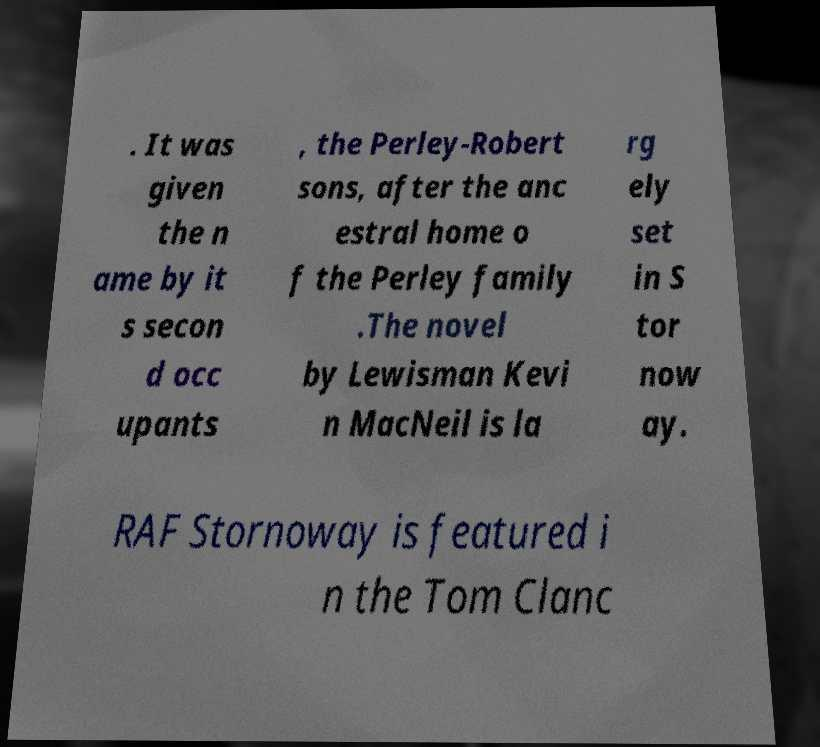There's text embedded in this image that I need extracted. Can you transcribe it verbatim? . It was given the n ame by it s secon d occ upants , the Perley-Robert sons, after the anc estral home o f the Perley family .The novel by Lewisman Kevi n MacNeil is la rg ely set in S tor now ay. RAF Stornoway is featured i n the Tom Clanc 